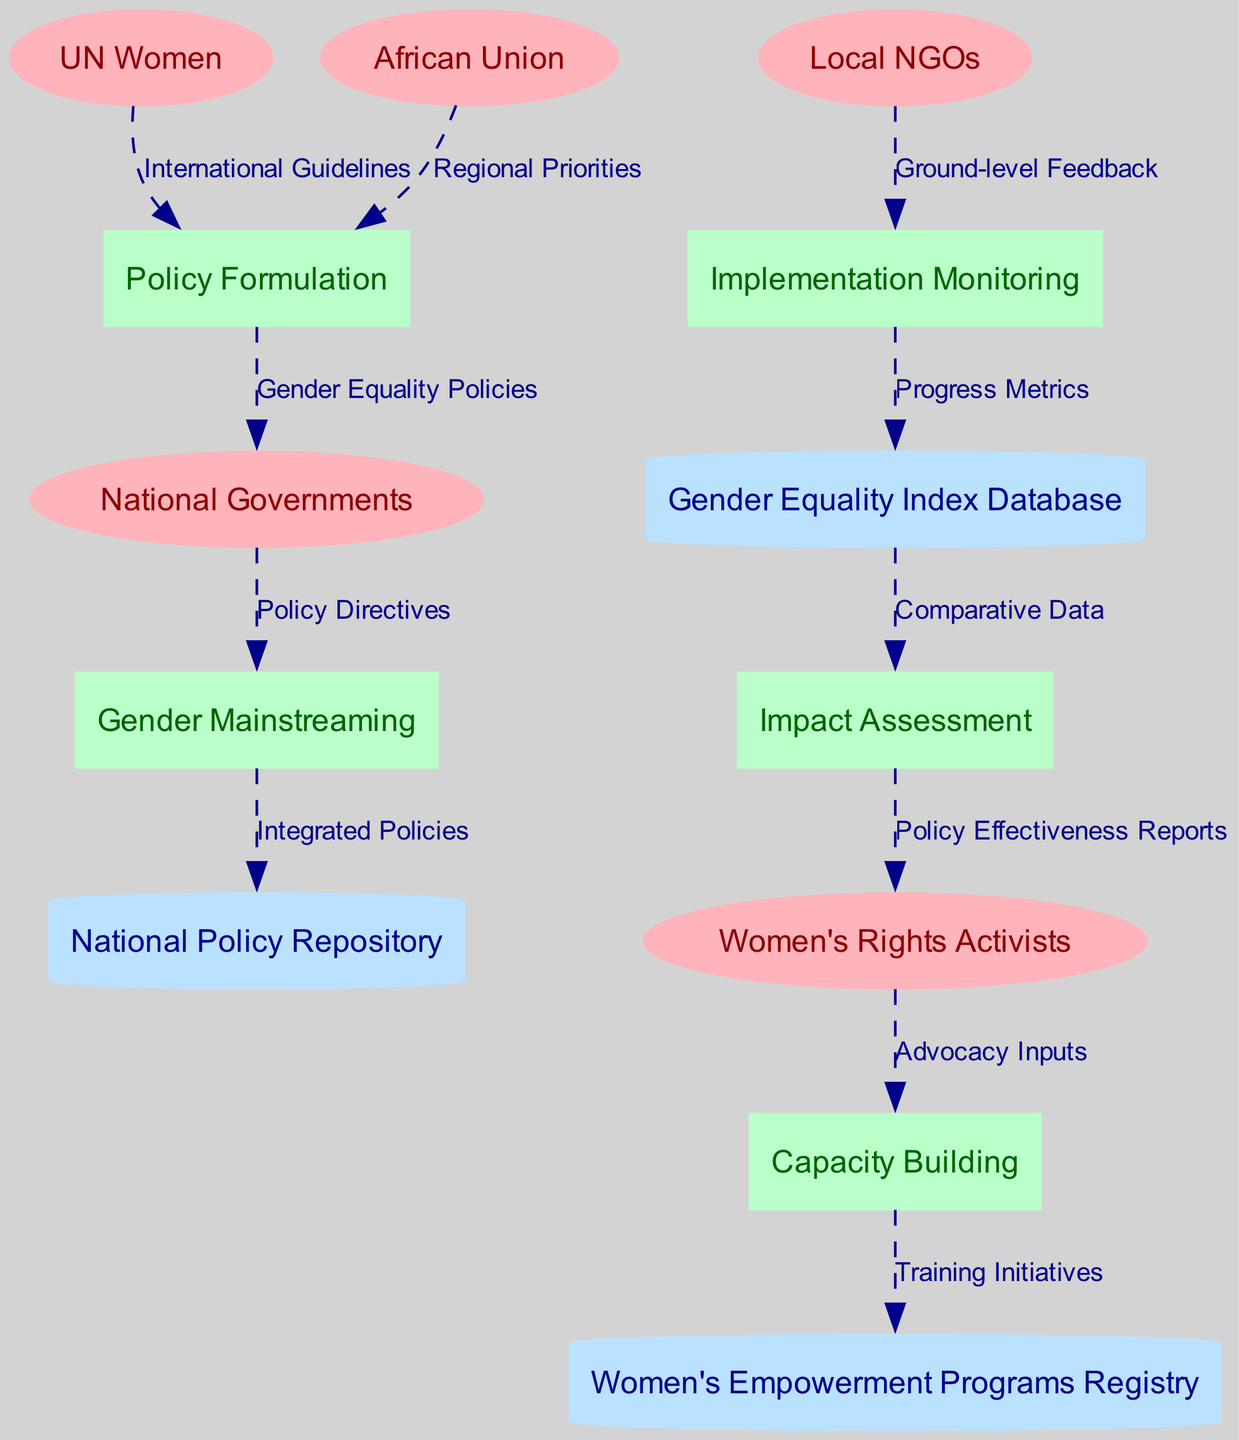What are the external entities in the diagram? The external entities listed in the diagram are UN Women, African Union, National Governments, Local NGOs, and Women's Rights Activists. These entities interact with the processes in the diagram.
Answer: UN Women, African Union, National Governments, Local NGOs, Women's Rights Activists How many processes are present in the diagram? The diagram contains five processes: Policy Formulation, Gender Mainstreaming, Implementation Monitoring, Impact Assessment, and Capacity Building. The number of processes can be counted directly from the list in the diagram.
Answer: 5 What flows from Gender Mainstreaming to the National Policy Repository? According to the diagram, the flow from Gender Mainstreaming to the National Policy Repository is "Integrated Policies." This can be identified by looking at the specific data flow labeled in the diagram.
Answer: Integrated Policies Which entity provides Ground-level Feedback? Ground-level Feedback is provided by Local NGOs, as indicated in the data flow from Local NGOs to Implementation Monitoring. This relationship can be observed directly in the diagram.
Answer: Local NGOs How do Women's Rights Activists contribute to the Capacity Building process? Women's Rights Activists contribute to the Capacity Building process by providing "Advocacy Inputs," which is shown in the data flow from Women's Rights Activists to Capacity Building in the diagram.
Answer: Advocacy Inputs What type of data is stored in the Gender Equality Index Database? The Gender Equality Index Database stores "Progress Metrics" based on the data flow from Implementation Monitoring. This information can be traced through the diagram's data flows.
Answer: Progress Metrics Explain the relationship between Policy Formulation and National Governments. The relationship is that Policy Formulation sends "Gender Equality Policies" to National Governments, which is a direct data flow observed in the diagram. This indicates that the policies formulated by this process are implemented by the national level.
Answer: Gender Equality Policies Which process follows Implementation Monitoring in the flow of data? The process that follows Implementation Monitoring is Impact Assessment, as indicated by the flow of "Comparative Data" from the Gender Equality Index Database to Impact Assessment. This demonstrates the sequence of processes upon monitoring.
Answer: Impact Assessment How does Capacity Building impact Women's Empowerment Programs Registry? Capacity Building impacts the Women's Empowerment Programs Registry by delivering "Training Initiatives," which is the output of the Capacity Building process according to the flow in the diagram. This highlights how capacity is built and subsequently registered.
Answer: Training Initiatives 